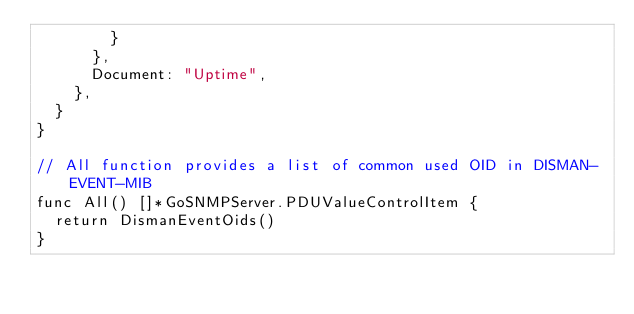<code> <loc_0><loc_0><loc_500><loc_500><_Go_>				}
			},
			Document: "Uptime",
		},
	}
}

// All function provides a list of common used OID in DISMAN-EVENT-MIB
func All() []*GoSNMPServer.PDUValueControlItem {
	return DismanEventOids()
}
</code> 